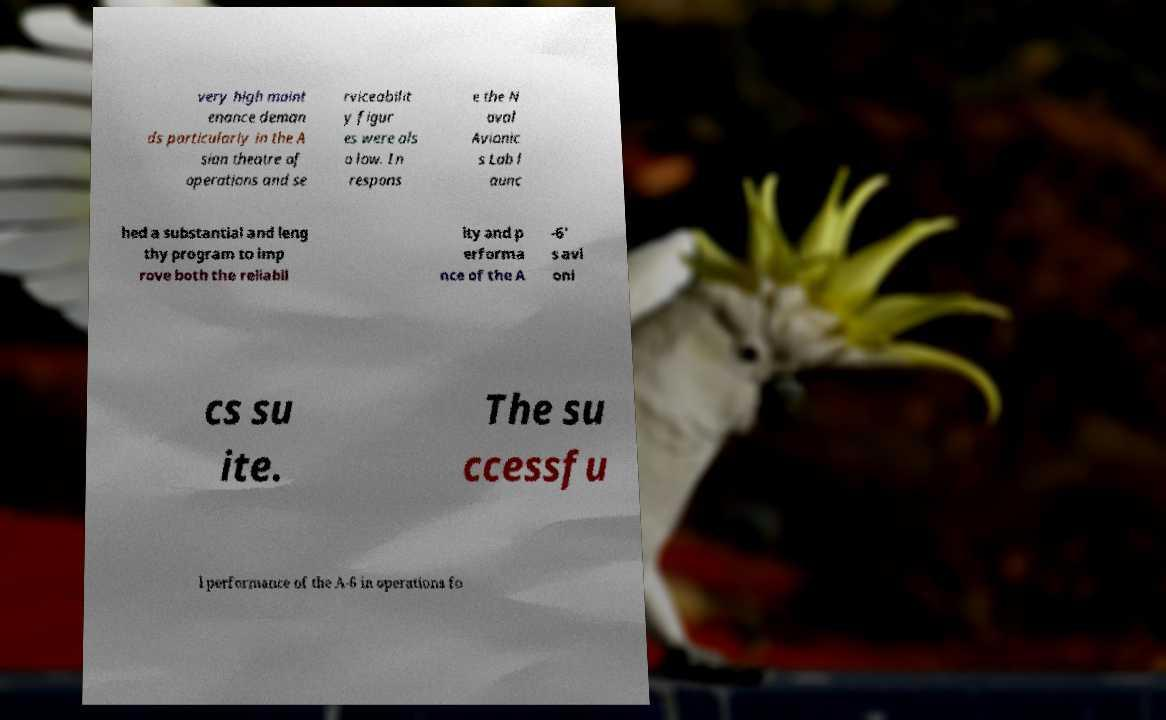Could you extract and type out the text from this image? very high maint enance deman ds particularly in the A sian theatre of operations and se rviceabilit y figur es were als o low. In respons e the N aval Avionic s Lab l aunc hed a substantial and leng thy program to imp rove both the reliabil ity and p erforma nce of the A -6' s avi oni cs su ite. The su ccessfu l performance of the A-6 in operations fo 